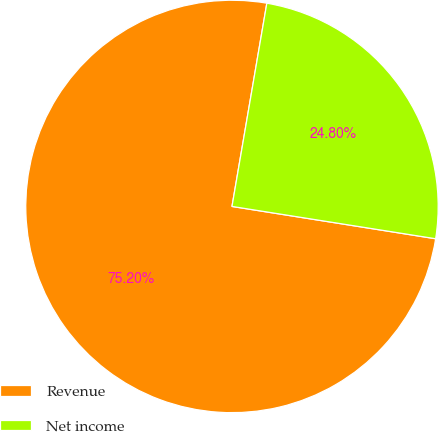Convert chart to OTSL. <chart><loc_0><loc_0><loc_500><loc_500><pie_chart><fcel>Revenue<fcel>Net income<nl><fcel>75.2%<fcel>24.8%<nl></chart> 